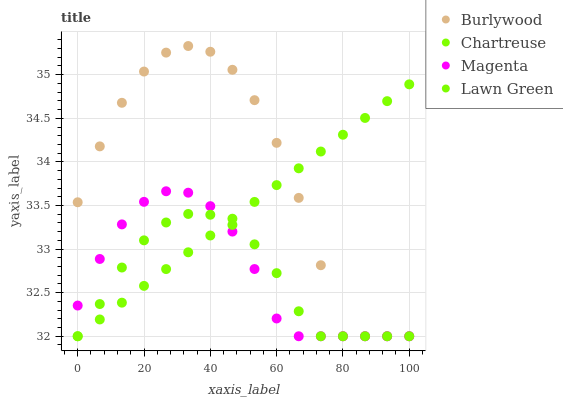Does Lawn Green have the minimum area under the curve?
Answer yes or no. Yes. Does Burlywood have the maximum area under the curve?
Answer yes or no. Yes. Does Chartreuse have the minimum area under the curve?
Answer yes or no. No. Does Chartreuse have the maximum area under the curve?
Answer yes or no. No. Is Chartreuse the smoothest?
Answer yes or no. Yes. Is Burlywood the roughest?
Answer yes or no. Yes. Is Lawn Green the smoothest?
Answer yes or no. No. Is Lawn Green the roughest?
Answer yes or no. No. Does Burlywood have the lowest value?
Answer yes or no. Yes. Does Burlywood have the highest value?
Answer yes or no. Yes. Does Chartreuse have the highest value?
Answer yes or no. No. Does Lawn Green intersect Chartreuse?
Answer yes or no. Yes. Is Lawn Green less than Chartreuse?
Answer yes or no. No. Is Lawn Green greater than Chartreuse?
Answer yes or no. No. 